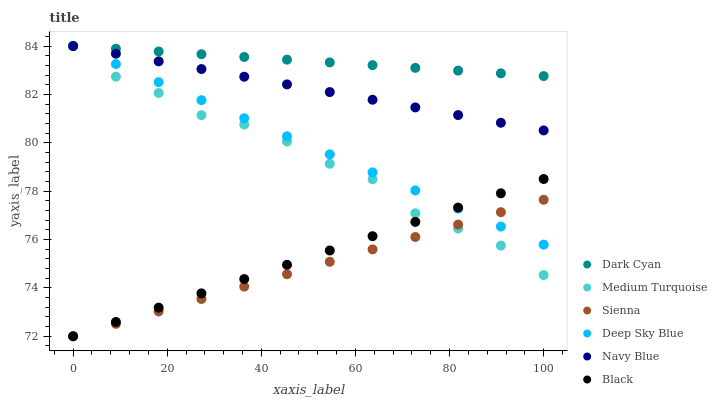Does Sienna have the minimum area under the curve?
Answer yes or no. Yes. Does Dark Cyan have the maximum area under the curve?
Answer yes or no. Yes. Does Navy Blue have the minimum area under the curve?
Answer yes or no. No. Does Navy Blue have the maximum area under the curve?
Answer yes or no. No. Is Black the smoothest?
Answer yes or no. Yes. Is Medium Turquoise the roughest?
Answer yes or no. Yes. Is Navy Blue the smoothest?
Answer yes or no. No. Is Navy Blue the roughest?
Answer yes or no. No. Does Sienna have the lowest value?
Answer yes or no. Yes. Does Navy Blue have the lowest value?
Answer yes or no. No. Does Dark Cyan have the highest value?
Answer yes or no. Yes. Does Sienna have the highest value?
Answer yes or no. No. Is Black less than Navy Blue?
Answer yes or no. Yes. Is Dark Cyan greater than Sienna?
Answer yes or no. Yes. Does Deep Sky Blue intersect Sienna?
Answer yes or no. Yes. Is Deep Sky Blue less than Sienna?
Answer yes or no. No. Is Deep Sky Blue greater than Sienna?
Answer yes or no. No. Does Black intersect Navy Blue?
Answer yes or no. No. 